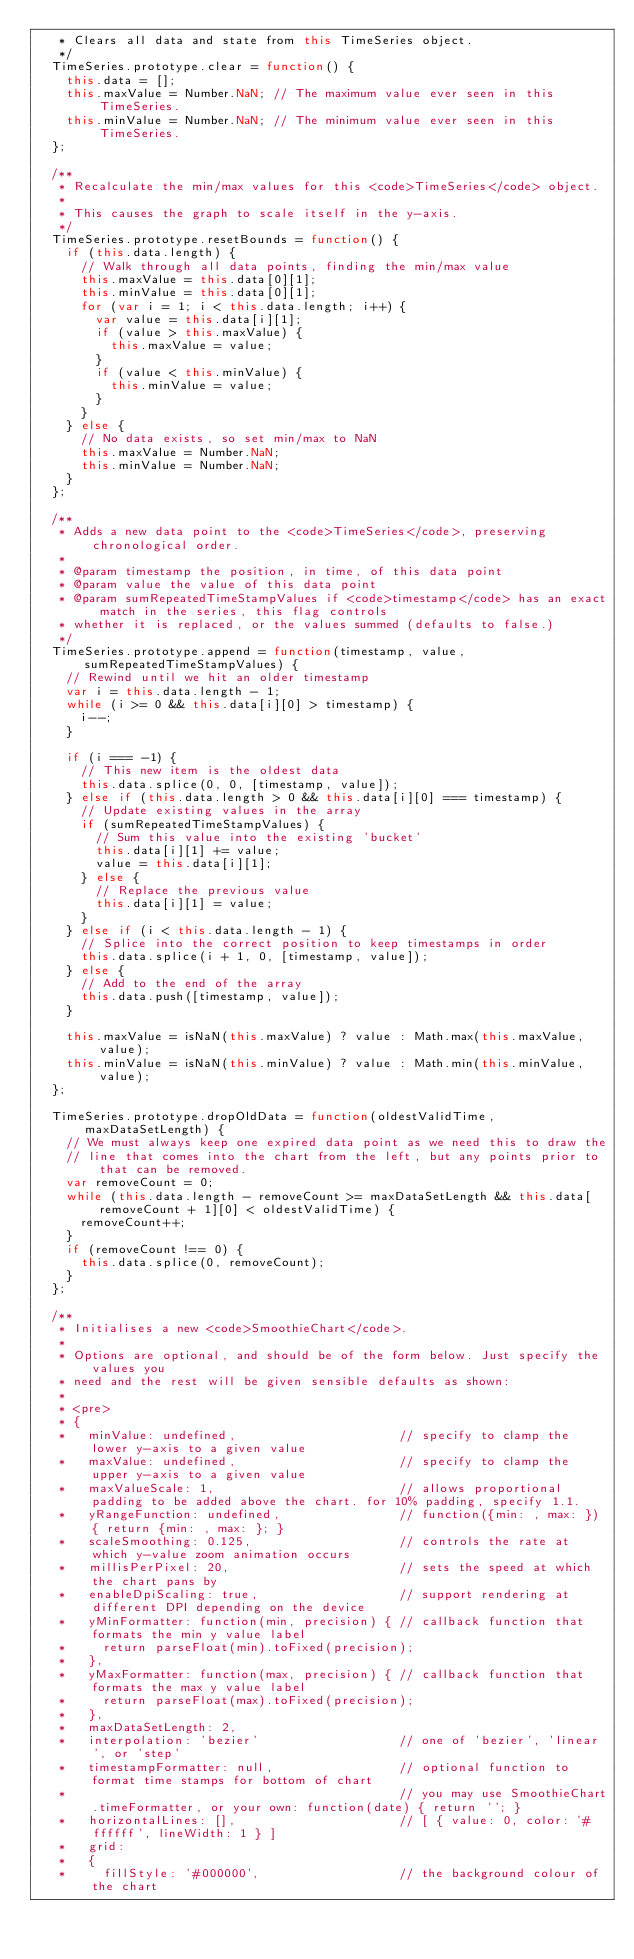<code> <loc_0><loc_0><loc_500><loc_500><_JavaScript_>   * Clears all data and state from this TimeSeries object.
   */
  TimeSeries.prototype.clear = function() {
    this.data = [];
    this.maxValue = Number.NaN; // The maximum value ever seen in this TimeSeries.
    this.minValue = Number.NaN; // The minimum value ever seen in this TimeSeries.
  };

  /**
   * Recalculate the min/max values for this <code>TimeSeries</code> object.
   *
   * This causes the graph to scale itself in the y-axis.
   */
  TimeSeries.prototype.resetBounds = function() {
    if (this.data.length) {
      // Walk through all data points, finding the min/max value
      this.maxValue = this.data[0][1];
      this.minValue = this.data[0][1];
      for (var i = 1; i < this.data.length; i++) {
        var value = this.data[i][1];
        if (value > this.maxValue) {
          this.maxValue = value;
        }
        if (value < this.minValue) {
          this.minValue = value;
        }
      }
    } else {
      // No data exists, so set min/max to NaN
      this.maxValue = Number.NaN;
      this.minValue = Number.NaN;
    }
  };

  /**
   * Adds a new data point to the <code>TimeSeries</code>, preserving chronological order.
   *
   * @param timestamp the position, in time, of this data point
   * @param value the value of this data point
   * @param sumRepeatedTimeStampValues if <code>timestamp</code> has an exact match in the series, this flag controls
   * whether it is replaced, or the values summed (defaults to false.)
   */
  TimeSeries.prototype.append = function(timestamp, value, sumRepeatedTimeStampValues) {
    // Rewind until we hit an older timestamp
    var i = this.data.length - 1;
    while (i >= 0 && this.data[i][0] > timestamp) {
      i--;
    }

    if (i === -1) {
      // This new item is the oldest data
      this.data.splice(0, 0, [timestamp, value]);
    } else if (this.data.length > 0 && this.data[i][0] === timestamp) {
      // Update existing values in the array
      if (sumRepeatedTimeStampValues) {
        // Sum this value into the existing 'bucket'
        this.data[i][1] += value;
        value = this.data[i][1];
      } else {
        // Replace the previous value
        this.data[i][1] = value;
      }
    } else if (i < this.data.length - 1) {
      // Splice into the correct position to keep timestamps in order
      this.data.splice(i + 1, 0, [timestamp, value]);
    } else {
      // Add to the end of the array
      this.data.push([timestamp, value]);
    }

    this.maxValue = isNaN(this.maxValue) ? value : Math.max(this.maxValue, value);
    this.minValue = isNaN(this.minValue) ? value : Math.min(this.minValue, value);
  };

  TimeSeries.prototype.dropOldData = function(oldestValidTime, maxDataSetLength) {
    // We must always keep one expired data point as we need this to draw the
    // line that comes into the chart from the left, but any points prior to that can be removed.
    var removeCount = 0;
    while (this.data.length - removeCount >= maxDataSetLength && this.data[removeCount + 1][0] < oldestValidTime) {
      removeCount++;
    }
    if (removeCount !== 0) {
      this.data.splice(0, removeCount);
    }
  };

  /**
   * Initialises a new <code>SmoothieChart</code>.
   *
   * Options are optional, and should be of the form below. Just specify the values you
   * need and the rest will be given sensible defaults as shown:
   *
   * <pre>
   * {
   *   minValue: undefined,                      // specify to clamp the lower y-axis to a given value
   *   maxValue: undefined,                      // specify to clamp the upper y-axis to a given value
   *   maxValueScale: 1,                         // allows proportional padding to be added above the chart. for 10% padding, specify 1.1.
   *   yRangeFunction: undefined,                // function({min: , max: }) { return {min: , max: }; }
   *   scaleSmoothing: 0.125,                    // controls the rate at which y-value zoom animation occurs
   *   millisPerPixel: 20,                       // sets the speed at which the chart pans by
   *   enableDpiScaling: true,                   // support rendering at different DPI depending on the device
   *   yMinFormatter: function(min, precision) { // callback function that formats the min y value label
   *     return parseFloat(min).toFixed(precision);
   *   },
   *   yMaxFormatter: function(max, precision) { // callback function that formats the max y value label
   *     return parseFloat(max).toFixed(precision);
   *   },
   *   maxDataSetLength: 2,
   *   interpolation: 'bezier'                   // one of 'bezier', 'linear', or 'step'
   *   timestampFormatter: null,                 // optional function to format time stamps for bottom of chart
   *                                             // you may use SmoothieChart.timeFormatter, or your own: function(date) { return ''; }
   *   horizontalLines: [],                      // [ { value: 0, color: '#ffffff', lineWidth: 1 } ]
   *   grid:
   *   {
   *     fillStyle: '#000000',                   // the background colour of the chart</code> 